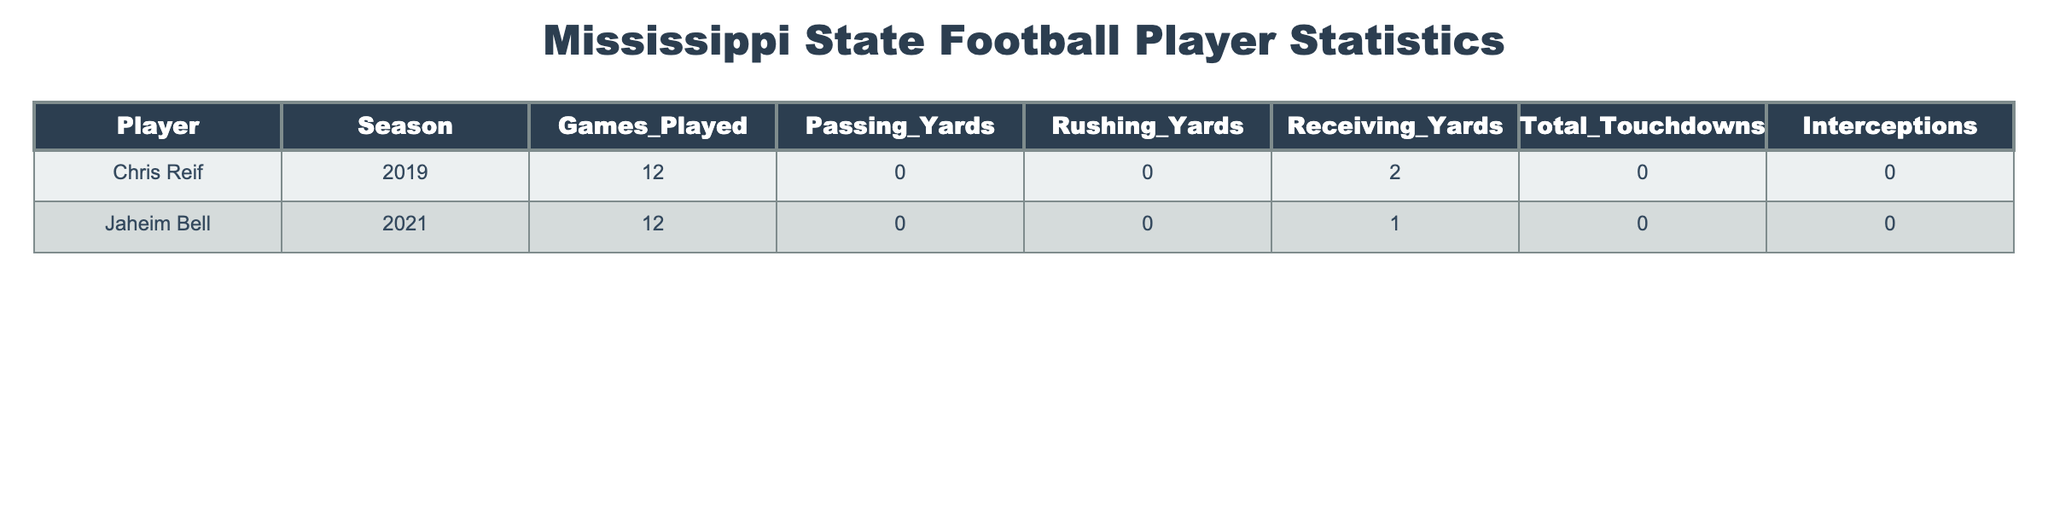What is the total number of games played by the players listed in the table? The table lists two players, Chris Reif and Jaheim Bell, each of whom played 12 games in their respective seasons. Adding these together, 12 + 12 = 24.
Answer: 24 Which player had the most total touchdowns? Chris Reif recorded 0 total touchdowns, while Jaheim Bell also recorded 0 total touchdowns. Therefore, neither player had total touchdowns.
Answer: 0 Did any player in the table record any passing yards? Both players listed, Chris Reif and Jaheim Bell, recorded 0 passing yards in their respective seasons. Therefore, the answer is no.
Answer: No What is the average rushing yards for the players in the table? The table shows that both players recorded 0 rushing yards. To find the average, we add 0 + 0 = 0, and then divide by the number of players, which is 2. Thus, the average is 0/2 = 0.
Answer: 0 Which player had receiving yards? Chris Reif had 2 receiving yards, while Jaheim Bell had 1 receiving yard. Thus, the player with receiving yards is Chris Reif.
Answer: Chris Reif Based on total touchdowns, which player had a better season, Chris Reif or Jaheim Bell? Both players recorded 0 total touchdowns in their seasons, so neither had a better season based on this statistic.
Answer: Neither What is the sum of passing and rushing yards for both players combined? Both players had 0 passing yards and 0 rushing yards. Therefore, the sum is (0 + 0) + (0 + 0) = 0.
Answer: 0 How many interceptions did the players have together? Chris Reif had 0 interceptions, and Jaheim Bell also had 0 interceptions. Therefore, their total is 0 + 0 = 0.
Answer: 0 Did any player contribute to their team's offensive statistics by scoring total touchdowns? Both players, Chris Reif and Jaheim Bell, recorded 0 total touchdowns. Hence, neither contributed to scoring.
Answer: No Which player had more receiving yards than the other? Chris Reif had 2 receiving yards, while Jaheim Bell had only 1 receiving yard. Thus, Chris Reif had more receiving yards.
Answer: Chris Reif 